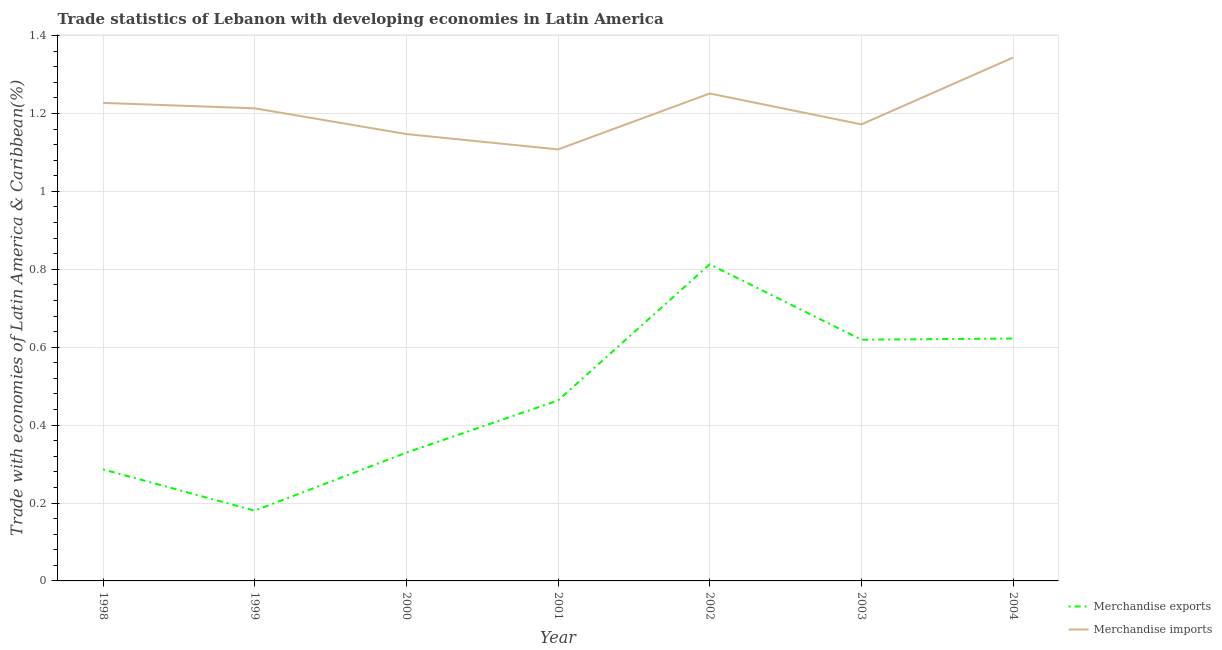Does the line corresponding to merchandise imports intersect with the line corresponding to merchandise exports?
Ensure brevity in your answer.  No. Is the number of lines equal to the number of legend labels?
Provide a succinct answer. Yes. What is the merchandise imports in 2004?
Offer a very short reply. 1.34. Across all years, what is the maximum merchandise imports?
Make the answer very short. 1.34. Across all years, what is the minimum merchandise exports?
Ensure brevity in your answer.  0.18. What is the total merchandise imports in the graph?
Offer a terse response. 8.46. What is the difference between the merchandise exports in 2000 and that in 2004?
Your answer should be very brief. -0.29. What is the difference between the merchandise exports in 2004 and the merchandise imports in 2001?
Provide a short and direct response. -0.49. What is the average merchandise imports per year?
Offer a terse response. 1.21. In the year 1999, what is the difference between the merchandise imports and merchandise exports?
Offer a very short reply. 1.03. What is the ratio of the merchandise imports in 1999 to that in 2001?
Offer a terse response. 1.1. Is the merchandise exports in 1999 less than that in 2001?
Offer a terse response. Yes. Is the difference between the merchandise imports in 1998 and 1999 greater than the difference between the merchandise exports in 1998 and 1999?
Keep it short and to the point. No. What is the difference between the highest and the second highest merchandise imports?
Your answer should be compact. 0.09. What is the difference between the highest and the lowest merchandise imports?
Make the answer very short. 0.24. Is the sum of the merchandise exports in 2002 and 2003 greater than the maximum merchandise imports across all years?
Give a very brief answer. Yes. Does the merchandise imports monotonically increase over the years?
Give a very brief answer. No. Does the graph contain any zero values?
Make the answer very short. No. Does the graph contain grids?
Provide a short and direct response. Yes. What is the title of the graph?
Offer a very short reply. Trade statistics of Lebanon with developing economies in Latin America. What is the label or title of the X-axis?
Provide a short and direct response. Year. What is the label or title of the Y-axis?
Offer a very short reply. Trade with economies of Latin America & Caribbean(%). What is the Trade with economies of Latin America & Caribbean(%) of Merchandise exports in 1998?
Provide a short and direct response. 0.29. What is the Trade with economies of Latin America & Caribbean(%) of Merchandise imports in 1998?
Provide a short and direct response. 1.23. What is the Trade with economies of Latin America & Caribbean(%) in Merchandise exports in 1999?
Make the answer very short. 0.18. What is the Trade with economies of Latin America & Caribbean(%) in Merchandise imports in 1999?
Make the answer very short. 1.21. What is the Trade with economies of Latin America & Caribbean(%) of Merchandise exports in 2000?
Keep it short and to the point. 0.33. What is the Trade with economies of Latin America & Caribbean(%) in Merchandise imports in 2000?
Your answer should be compact. 1.15. What is the Trade with economies of Latin America & Caribbean(%) in Merchandise exports in 2001?
Give a very brief answer. 0.46. What is the Trade with economies of Latin America & Caribbean(%) of Merchandise imports in 2001?
Make the answer very short. 1.11. What is the Trade with economies of Latin America & Caribbean(%) of Merchandise exports in 2002?
Your answer should be compact. 0.81. What is the Trade with economies of Latin America & Caribbean(%) of Merchandise imports in 2002?
Make the answer very short. 1.25. What is the Trade with economies of Latin America & Caribbean(%) in Merchandise exports in 2003?
Make the answer very short. 0.62. What is the Trade with economies of Latin America & Caribbean(%) in Merchandise imports in 2003?
Make the answer very short. 1.17. What is the Trade with economies of Latin America & Caribbean(%) of Merchandise exports in 2004?
Ensure brevity in your answer.  0.62. What is the Trade with economies of Latin America & Caribbean(%) of Merchandise imports in 2004?
Make the answer very short. 1.34. Across all years, what is the maximum Trade with economies of Latin America & Caribbean(%) of Merchandise exports?
Offer a terse response. 0.81. Across all years, what is the maximum Trade with economies of Latin America & Caribbean(%) in Merchandise imports?
Offer a terse response. 1.34. Across all years, what is the minimum Trade with economies of Latin America & Caribbean(%) in Merchandise exports?
Make the answer very short. 0.18. Across all years, what is the minimum Trade with economies of Latin America & Caribbean(%) in Merchandise imports?
Make the answer very short. 1.11. What is the total Trade with economies of Latin America & Caribbean(%) of Merchandise exports in the graph?
Give a very brief answer. 3.31. What is the total Trade with economies of Latin America & Caribbean(%) of Merchandise imports in the graph?
Your answer should be very brief. 8.46. What is the difference between the Trade with economies of Latin America & Caribbean(%) of Merchandise exports in 1998 and that in 1999?
Keep it short and to the point. 0.11. What is the difference between the Trade with economies of Latin America & Caribbean(%) of Merchandise imports in 1998 and that in 1999?
Keep it short and to the point. 0.01. What is the difference between the Trade with economies of Latin America & Caribbean(%) of Merchandise exports in 1998 and that in 2000?
Provide a succinct answer. -0.04. What is the difference between the Trade with economies of Latin America & Caribbean(%) in Merchandise imports in 1998 and that in 2000?
Keep it short and to the point. 0.08. What is the difference between the Trade with economies of Latin America & Caribbean(%) of Merchandise exports in 1998 and that in 2001?
Keep it short and to the point. -0.18. What is the difference between the Trade with economies of Latin America & Caribbean(%) in Merchandise imports in 1998 and that in 2001?
Make the answer very short. 0.12. What is the difference between the Trade with economies of Latin America & Caribbean(%) in Merchandise exports in 1998 and that in 2002?
Ensure brevity in your answer.  -0.53. What is the difference between the Trade with economies of Latin America & Caribbean(%) in Merchandise imports in 1998 and that in 2002?
Provide a succinct answer. -0.02. What is the difference between the Trade with economies of Latin America & Caribbean(%) of Merchandise exports in 1998 and that in 2003?
Your response must be concise. -0.33. What is the difference between the Trade with economies of Latin America & Caribbean(%) in Merchandise imports in 1998 and that in 2003?
Provide a short and direct response. 0.06. What is the difference between the Trade with economies of Latin America & Caribbean(%) in Merchandise exports in 1998 and that in 2004?
Keep it short and to the point. -0.34. What is the difference between the Trade with economies of Latin America & Caribbean(%) of Merchandise imports in 1998 and that in 2004?
Give a very brief answer. -0.12. What is the difference between the Trade with economies of Latin America & Caribbean(%) in Merchandise exports in 1999 and that in 2000?
Ensure brevity in your answer.  -0.15. What is the difference between the Trade with economies of Latin America & Caribbean(%) in Merchandise imports in 1999 and that in 2000?
Offer a terse response. 0.07. What is the difference between the Trade with economies of Latin America & Caribbean(%) of Merchandise exports in 1999 and that in 2001?
Provide a short and direct response. -0.28. What is the difference between the Trade with economies of Latin America & Caribbean(%) of Merchandise imports in 1999 and that in 2001?
Offer a very short reply. 0.11. What is the difference between the Trade with economies of Latin America & Caribbean(%) of Merchandise exports in 1999 and that in 2002?
Offer a very short reply. -0.63. What is the difference between the Trade with economies of Latin America & Caribbean(%) in Merchandise imports in 1999 and that in 2002?
Give a very brief answer. -0.04. What is the difference between the Trade with economies of Latin America & Caribbean(%) in Merchandise exports in 1999 and that in 2003?
Give a very brief answer. -0.44. What is the difference between the Trade with economies of Latin America & Caribbean(%) of Merchandise imports in 1999 and that in 2003?
Provide a short and direct response. 0.04. What is the difference between the Trade with economies of Latin America & Caribbean(%) in Merchandise exports in 1999 and that in 2004?
Make the answer very short. -0.44. What is the difference between the Trade with economies of Latin America & Caribbean(%) of Merchandise imports in 1999 and that in 2004?
Your answer should be compact. -0.13. What is the difference between the Trade with economies of Latin America & Caribbean(%) in Merchandise exports in 2000 and that in 2001?
Ensure brevity in your answer.  -0.13. What is the difference between the Trade with economies of Latin America & Caribbean(%) of Merchandise imports in 2000 and that in 2001?
Provide a short and direct response. 0.04. What is the difference between the Trade with economies of Latin America & Caribbean(%) in Merchandise exports in 2000 and that in 2002?
Offer a terse response. -0.48. What is the difference between the Trade with economies of Latin America & Caribbean(%) of Merchandise imports in 2000 and that in 2002?
Provide a succinct answer. -0.1. What is the difference between the Trade with economies of Latin America & Caribbean(%) of Merchandise exports in 2000 and that in 2003?
Your answer should be compact. -0.29. What is the difference between the Trade with economies of Latin America & Caribbean(%) of Merchandise imports in 2000 and that in 2003?
Offer a terse response. -0.02. What is the difference between the Trade with economies of Latin America & Caribbean(%) of Merchandise exports in 2000 and that in 2004?
Offer a terse response. -0.29. What is the difference between the Trade with economies of Latin America & Caribbean(%) in Merchandise imports in 2000 and that in 2004?
Keep it short and to the point. -0.2. What is the difference between the Trade with economies of Latin America & Caribbean(%) in Merchandise exports in 2001 and that in 2002?
Your response must be concise. -0.35. What is the difference between the Trade with economies of Latin America & Caribbean(%) of Merchandise imports in 2001 and that in 2002?
Provide a short and direct response. -0.14. What is the difference between the Trade with economies of Latin America & Caribbean(%) of Merchandise exports in 2001 and that in 2003?
Ensure brevity in your answer.  -0.16. What is the difference between the Trade with economies of Latin America & Caribbean(%) in Merchandise imports in 2001 and that in 2003?
Keep it short and to the point. -0.06. What is the difference between the Trade with economies of Latin America & Caribbean(%) of Merchandise exports in 2001 and that in 2004?
Offer a very short reply. -0.16. What is the difference between the Trade with economies of Latin America & Caribbean(%) in Merchandise imports in 2001 and that in 2004?
Offer a very short reply. -0.24. What is the difference between the Trade with economies of Latin America & Caribbean(%) in Merchandise exports in 2002 and that in 2003?
Your answer should be very brief. 0.19. What is the difference between the Trade with economies of Latin America & Caribbean(%) in Merchandise imports in 2002 and that in 2003?
Your answer should be compact. 0.08. What is the difference between the Trade with economies of Latin America & Caribbean(%) of Merchandise exports in 2002 and that in 2004?
Make the answer very short. 0.19. What is the difference between the Trade with economies of Latin America & Caribbean(%) of Merchandise imports in 2002 and that in 2004?
Your answer should be compact. -0.09. What is the difference between the Trade with economies of Latin America & Caribbean(%) of Merchandise exports in 2003 and that in 2004?
Provide a succinct answer. -0. What is the difference between the Trade with economies of Latin America & Caribbean(%) of Merchandise imports in 2003 and that in 2004?
Your response must be concise. -0.17. What is the difference between the Trade with economies of Latin America & Caribbean(%) in Merchandise exports in 1998 and the Trade with economies of Latin America & Caribbean(%) in Merchandise imports in 1999?
Offer a very short reply. -0.93. What is the difference between the Trade with economies of Latin America & Caribbean(%) of Merchandise exports in 1998 and the Trade with economies of Latin America & Caribbean(%) of Merchandise imports in 2000?
Make the answer very short. -0.86. What is the difference between the Trade with economies of Latin America & Caribbean(%) of Merchandise exports in 1998 and the Trade with economies of Latin America & Caribbean(%) of Merchandise imports in 2001?
Make the answer very short. -0.82. What is the difference between the Trade with economies of Latin America & Caribbean(%) in Merchandise exports in 1998 and the Trade with economies of Latin America & Caribbean(%) in Merchandise imports in 2002?
Your answer should be compact. -0.96. What is the difference between the Trade with economies of Latin America & Caribbean(%) in Merchandise exports in 1998 and the Trade with economies of Latin America & Caribbean(%) in Merchandise imports in 2003?
Give a very brief answer. -0.89. What is the difference between the Trade with economies of Latin America & Caribbean(%) of Merchandise exports in 1998 and the Trade with economies of Latin America & Caribbean(%) of Merchandise imports in 2004?
Offer a very short reply. -1.06. What is the difference between the Trade with economies of Latin America & Caribbean(%) of Merchandise exports in 1999 and the Trade with economies of Latin America & Caribbean(%) of Merchandise imports in 2000?
Give a very brief answer. -0.97. What is the difference between the Trade with economies of Latin America & Caribbean(%) in Merchandise exports in 1999 and the Trade with economies of Latin America & Caribbean(%) in Merchandise imports in 2001?
Keep it short and to the point. -0.93. What is the difference between the Trade with economies of Latin America & Caribbean(%) of Merchandise exports in 1999 and the Trade with economies of Latin America & Caribbean(%) of Merchandise imports in 2002?
Offer a very short reply. -1.07. What is the difference between the Trade with economies of Latin America & Caribbean(%) of Merchandise exports in 1999 and the Trade with economies of Latin America & Caribbean(%) of Merchandise imports in 2003?
Your answer should be compact. -0.99. What is the difference between the Trade with economies of Latin America & Caribbean(%) of Merchandise exports in 1999 and the Trade with economies of Latin America & Caribbean(%) of Merchandise imports in 2004?
Keep it short and to the point. -1.16. What is the difference between the Trade with economies of Latin America & Caribbean(%) of Merchandise exports in 2000 and the Trade with economies of Latin America & Caribbean(%) of Merchandise imports in 2001?
Your answer should be compact. -0.78. What is the difference between the Trade with economies of Latin America & Caribbean(%) in Merchandise exports in 2000 and the Trade with economies of Latin America & Caribbean(%) in Merchandise imports in 2002?
Provide a succinct answer. -0.92. What is the difference between the Trade with economies of Latin America & Caribbean(%) in Merchandise exports in 2000 and the Trade with economies of Latin America & Caribbean(%) in Merchandise imports in 2003?
Provide a short and direct response. -0.84. What is the difference between the Trade with economies of Latin America & Caribbean(%) in Merchandise exports in 2000 and the Trade with economies of Latin America & Caribbean(%) in Merchandise imports in 2004?
Provide a short and direct response. -1.01. What is the difference between the Trade with economies of Latin America & Caribbean(%) in Merchandise exports in 2001 and the Trade with economies of Latin America & Caribbean(%) in Merchandise imports in 2002?
Give a very brief answer. -0.79. What is the difference between the Trade with economies of Latin America & Caribbean(%) of Merchandise exports in 2001 and the Trade with economies of Latin America & Caribbean(%) of Merchandise imports in 2003?
Your answer should be compact. -0.71. What is the difference between the Trade with economies of Latin America & Caribbean(%) in Merchandise exports in 2001 and the Trade with economies of Latin America & Caribbean(%) in Merchandise imports in 2004?
Offer a terse response. -0.88. What is the difference between the Trade with economies of Latin America & Caribbean(%) in Merchandise exports in 2002 and the Trade with economies of Latin America & Caribbean(%) in Merchandise imports in 2003?
Make the answer very short. -0.36. What is the difference between the Trade with economies of Latin America & Caribbean(%) of Merchandise exports in 2002 and the Trade with economies of Latin America & Caribbean(%) of Merchandise imports in 2004?
Your answer should be very brief. -0.53. What is the difference between the Trade with economies of Latin America & Caribbean(%) of Merchandise exports in 2003 and the Trade with economies of Latin America & Caribbean(%) of Merchandise imports in 2004?
Your answer should be compact. -0.72. What is the average Trade with economies of Latin America & Caribbean(%) of Merchandise exports per year?
Your answer should be very brief. 0.47. What is the average Trade with economies of Latin America & Caribbean(%) of Merchandise imports per year?
Offer a terse response. 1.21. In the year 1998, what is the difference between the Trade with economies of Latin America & Caribbean(%) of Merchandise exports and Trade with economies of Latin America & Caribbean(%) of Merchandise imports?
Provide a succinct answer. -0.94. In the year 1999, what is the difference between the Trade with economies of Latin America & Caribbean(%) of Merchandise exports and Trade with economies of Latin America & Caribbean(%) of Merchandise imports?
Your answer should be very brief. -1.03. In the year 2000, what is the difference between the Trade with economies of Latin America & Caribbean(%) in Merchandise exports and Trade with economies of Latin America & Caribbean(%) in Merchandise imports?
Ensure brevity in your answer.  -0.82. In the year 2001, what is the difference between the Trade with economies of Latin America & Caribbean(%) of Merchandise exports and Trade with economies of Latin America & Caribbean(%) of Merchandise imports?
Offer a terse response. -0.64. In the year 2002, what is the difference between the Trade with economies of Latin America & Caribbean(%) of Merchandise exports and Trade with economies of Latin America & Caribbean(%) of Merchandise imports?
Offer a very short reply. -0.44. In the year 2003, what is the difference between the Trade with economies of Latin America & Caribbean(%) in Merchandise exports and Trade with economies of Latin America & Caribbean(%) in Merchandise imports?
Offer a terse response. -0.55. In the year 2004, what is the difference between the Trade with economies of Latin America & Caribbean(%) of Merchandise exports and Trade with economies of Latin America & Caribbean(%) of Merchandise imports?
Your response must be concise. -0.72. What is the ratio of the Trade with economies of Latin America & Caribbean(%) of Merchandise exports in 1998 to that in 1999?
Keep it short and to the point. 1.59. What is the ratio of the Trade with economies of Latin America & Caribbean(%) in Merchandise imports in 1998 to that in 1999?
Offer a terse response. 1.01. What is the ratio of the Trade with economies of Latin America & Caribbean(%) in Merchandise exports in 1998 to that in 2000?
Provide a short and direct response. 0.87. What is the ratio of the Trade with economies of Latin America & Caribbean(%) in Merchandise imports in 1998 to that in 2000?
Make the answer very short. 1.07. What is the ratio of the Trade with economies of Latin America & Caribbean(%) of Merchandise exports in 1998 to that in 2001?
Make the answer very short. 0.62. What is the ratio of the Trade with economies of Latin America & Caribbean(%) in Merchandise imports in 1998 to that in 2001?
Offer a terse response. 1.11. What is the ratio of the Trade with economies of Latin America & Caribbean(%) in Merchandise exports in 1998 to that in 2002?
Make the answer very short. 0.35. What is the ratio of the Trade with economies of Latin America & Caribbean(%) of Merchandise imports in 1998 to that in 2002?
Provide a short and direct response. 0.98. What is the ratio of the Trade with economies of Latin America & Caribbean(%) of Merchandise exports in 1998 to that in 2003?
Offer a very short reply. 0.46. What is the ratio of the Trade with economies of Latin America & Caribbean(%) in Merchandise imports in 1998 to that in 2003?
Your answer should be compact. 1.05. What is the ratio of the Trade with economies of Latin America & Caribbean(%) of Merchandise exports in 1998 to that in 2004?
Make the answer very short. 0.46. What is the ratio of the Trade with economies of Latin America & Caribbean(%) in Merchandise imports in 1998 to that in 2004?
Give a very brief answer. 0.91. What is the ratio of the Trade with economies of Latin America & Caribbean(%) in Merchandise exports in 1999 to that in 2000?
Your answer should be compact. 0.55. What is the ratio of the Trade with economies of Latin America & Caribbean(%) in Merchandise imports in 1999 to that in 2000?
Provide a succinct answer. 1.06. What is the ratio of the Trade with economies of Latin America & Caribbean(%) of Merchandise exports in 1999 to that in 2001?
Keep it short and to the point. 0.39. What is the ratio of the Trade with economies of Latin America & Caribbean(%) in Merchandise imports in 1999 to that in 2001?
Offer a very short reply. 1.1. What is the ratio of the Trade with economies of Latin America & Caribbean(%) in Merchandise exports in 1999 to that in 2002?
Give a very brief answer. 0.22. What is the ratio of the Trade with economies of Latin America & Caribbean(%) in Merchandise imports in 1999 to that in 2002?
Provide a succinct answer. 0.97. What is the ratio of the Trade with economies of Latin America & Caribbean(%) of Merchandise exports in 1999 to that in 2003?
Keep it short and to the point. 0.29. What is the ratio of the Trade with economies of Latin America & Caribbean(%) in Merchandise imports in 1999 to that in 2003?
Keep it short and to the point. 1.04. What is the ratio of the Trade with economies of Latin America & Caribbean(%) of Merchandise exports in 1999 to that in 2004?
Your answer should be compact. 0.29. What is the ratio of the Trade with economies of Latin America & Caribbean(%) in Merchandise imports in 1999 to that in 2004?
Give a very brief answer. 0.9. What is the ratio of the Trade with economies of Latin America & Caribbean(%) of Merchandise exports in 2000 to that in 2001?
Offer a very short reply. 0.71. What is the ratio of the Trade with economies of Latin America & Caribbean(%) in Merchandise imports in 2000 to that in 2001?
Provide a short and direct response. 1.04. What is the ratio of the Trade with economies of Latin America & Caribbean(%) in Merchandise exports in 2000 to that in 2002?
Your answer should be very brief. 0.41. What is the ratio of the Trade with economies of Latin America & Caribbean(%) of Merchandise exports in 2000 to that in 2003?
Keep it short and to the point. 0.53. What is the ratio of the Trade with economies of Latin America & Caribbean(%) in Merchandise imports in 2000 to that in 2003?
Make the answer very short. 0.98. What is the ratio of the Trade with economies of Latin America & Caribbean(%) of Merchandise exports in 2000 to that in 2004?
Ensure brevity in your answer.  0.53. What is the ratio of the Trade with economies of Latin America & Caribbean(%) in Merchandise imports in 2000 to that in 2004?
Your answer should be compact. 0.85. What is the ratio of the Trade with economies of Latin America & Caribbean(%) in Merchandise exports in 2001 to that in 2002?
Your answer should be compact. 0.57. What is the ratio of the Trade with economies of Latin America & Caribbean(%) in Merchandise imports in 2001 to that in 2002?
Offer a terse response. 0.89. What is the ratio of the Trade with economies of Latin America & Caribbean(%) of Merchandise exports in 2001 to that in 2003?
Ensure brevity in your answer.  0.75. What is the ratio of the Trade with economies of Latin America & Caribbean(%) of Merchandise imports in 2001 to that in 2003?
Your answer should be very brief. 0.95. What is the ratio of the Trade with economies of Latin America & Caribbean(%) in Merchandise exports in 2001 to that in 2004?
Your answer should be very brief. 0.74. What is the ratio of the Trade with economies of Latin America & Caribbean(%) of Merchandise imports in 2001 to that in 2004?
Provide a succinct answer. 0.82. What is the ratio of the Trade with economies of Latin America & Caribbean(%) in Merchandise exports in 2002 to that in 2003?
Provide a succinct answer. 1.31. What is the ratio of the Trade with economies of Latin America & Caribbean(%) in Merchandise imports in 2002 to that in 2003?
Offer a very short reply. 1.07. What is the ratio of the Trade with economies of Latin America & Caribbean(%) in Merchandise exports in 2002 to that in 2004?
Provide a succinct answer. 1.31. What is the ratio of the Trade with economies of Latin America & Caribbean(%) of Merchandise imports in 2002 to that in 2004?
Give a very brief answer. 0.93. What is the ratio of the Trade with economies of Latin America & Caribbean(%) of Merchandise exports in 2003 to that in 2004?
Make the answer very short. 1. What is the ratio of the Trade with economies of Latin America & Caribbean(%) of Merchandise imports in 2003 to that in 2004?
Ensure brevity in your answer.  0.87. What is the difference between the highest and the second highest Trade with economies of Latin America & Caribbean(%) of Merchandise exports?
Provide a succinct answer. 0.19. What is the difference between the highest and the second highest Trade with economies of Latin America & Caribbean(%) in Merchandise imports?
Your response must be concise. 0.09. What is the difference between the highest and the lowest Trade with economies of Latin America & Caribbean(%) of Merchandise exports?
Your answer should be very brief. 0.63. What is the difference between the highest and the lowest Trade with economies of Latin America & Caribbean(%) in Merchandise imports?
Your answer should be compact. 0.24. 